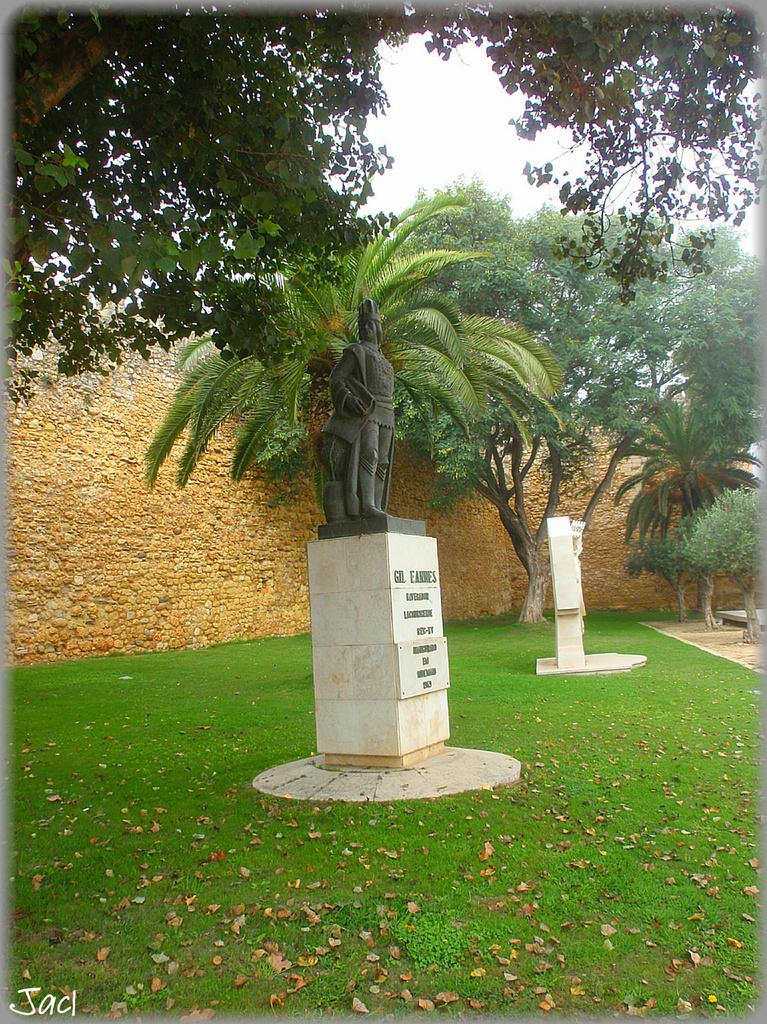What is the main subject in the image? There is a statue in the image. What can be seen in the background of the image? There is a wall, trees, and the sky visible in the background of the image. What is the color of the wall in the background? The wall in the background is in brown color. What is the color of the trees in the background? The trees in the background are in green color. What is the color of the sky in the background? The sky in the background is in white color. How much friction is present between the statue and the ground in the image? The image does not provide information about friction between the statue and the ground. 